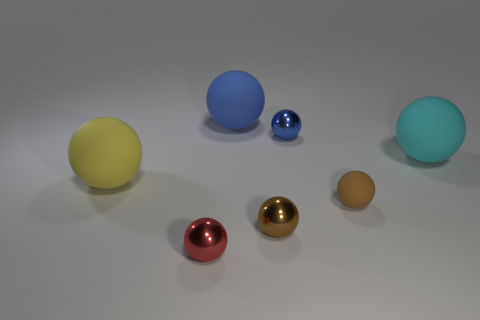Do the yellow ball and the red object have the same size?
Give a very brief answer. No. How big is the blue metallic sphere?
Provide a short and direct response. Small. What shape is the other object that is the same color as the tiny rubber thing?
Your response must be concise. Sphere. Are there more red objects than large purple objects?
Your answer should be compact. Yes. There is a rubber object that is in front of the big thing that is in front of the large rubber sphere on the right side of the blue rubber thing; what color is it?
Provide a succinct answer. Brown. Is the shape of the big cyan thing that is behind the red thing the same as  the large yellow rubber thing?
Offer a terse response. Yes. What color is the matte thing that is the same size as the blue metallic object?
Your response must be concise. Brown. What number of green blocks are there?
Your answer should be very brief. 0. Is the material of the tiny ball behind the yellow matte thing the same as the big blue ball?
Give a very brief answer. No. What is the material of the large thing that is both behind the big yellow matte thing and on the left side of the big cyan matte sphere?
Give a very brief answer. Rubber. 